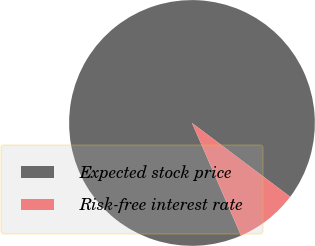Convert chart. <chart><loc_0><loc_0><loc_500><loc_500><pie_chart><fcel>Expected stock price<fcel>Risk-free interest rate<nl><fcel>91.8%<fcel>8.2%<nl></chart> 